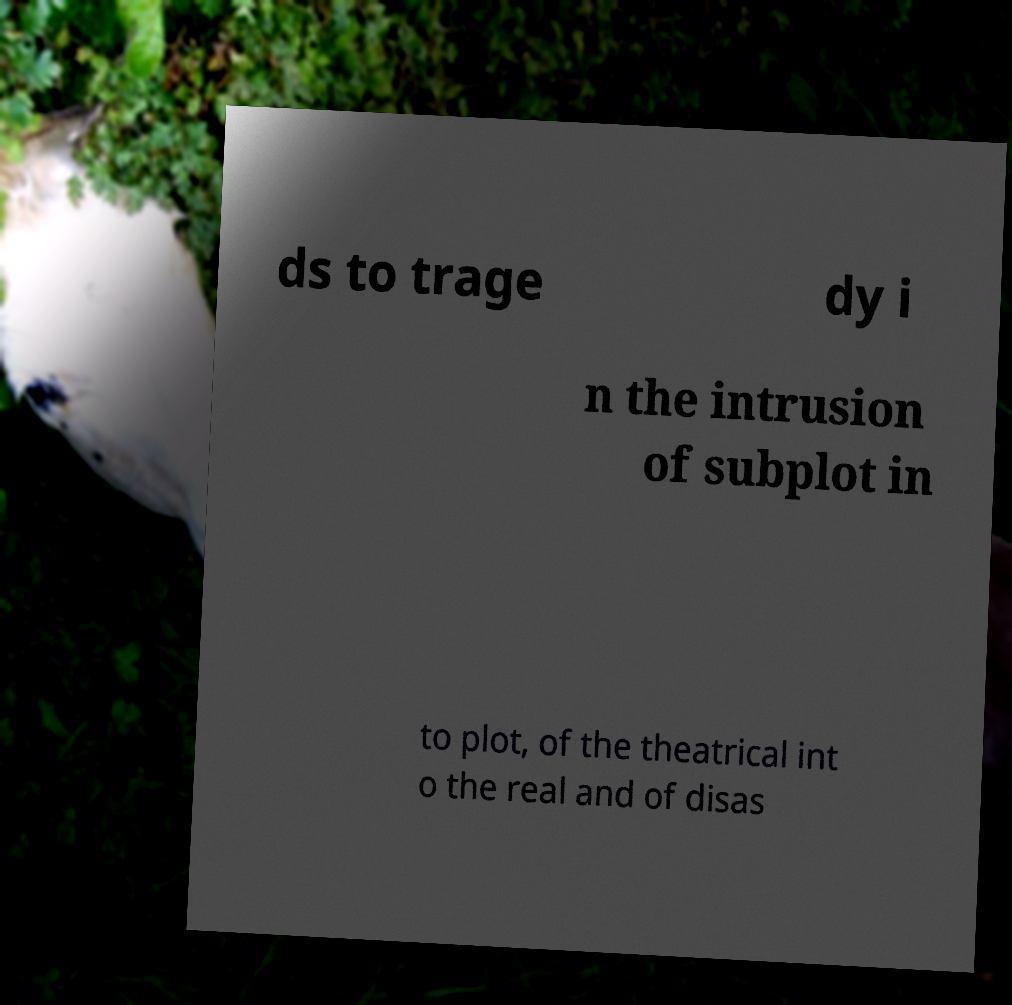Could you extract and type out the text from this image? ds to trage dy i n the intrusion of subplot in to plot, of the theatrical int o the real and of disas 